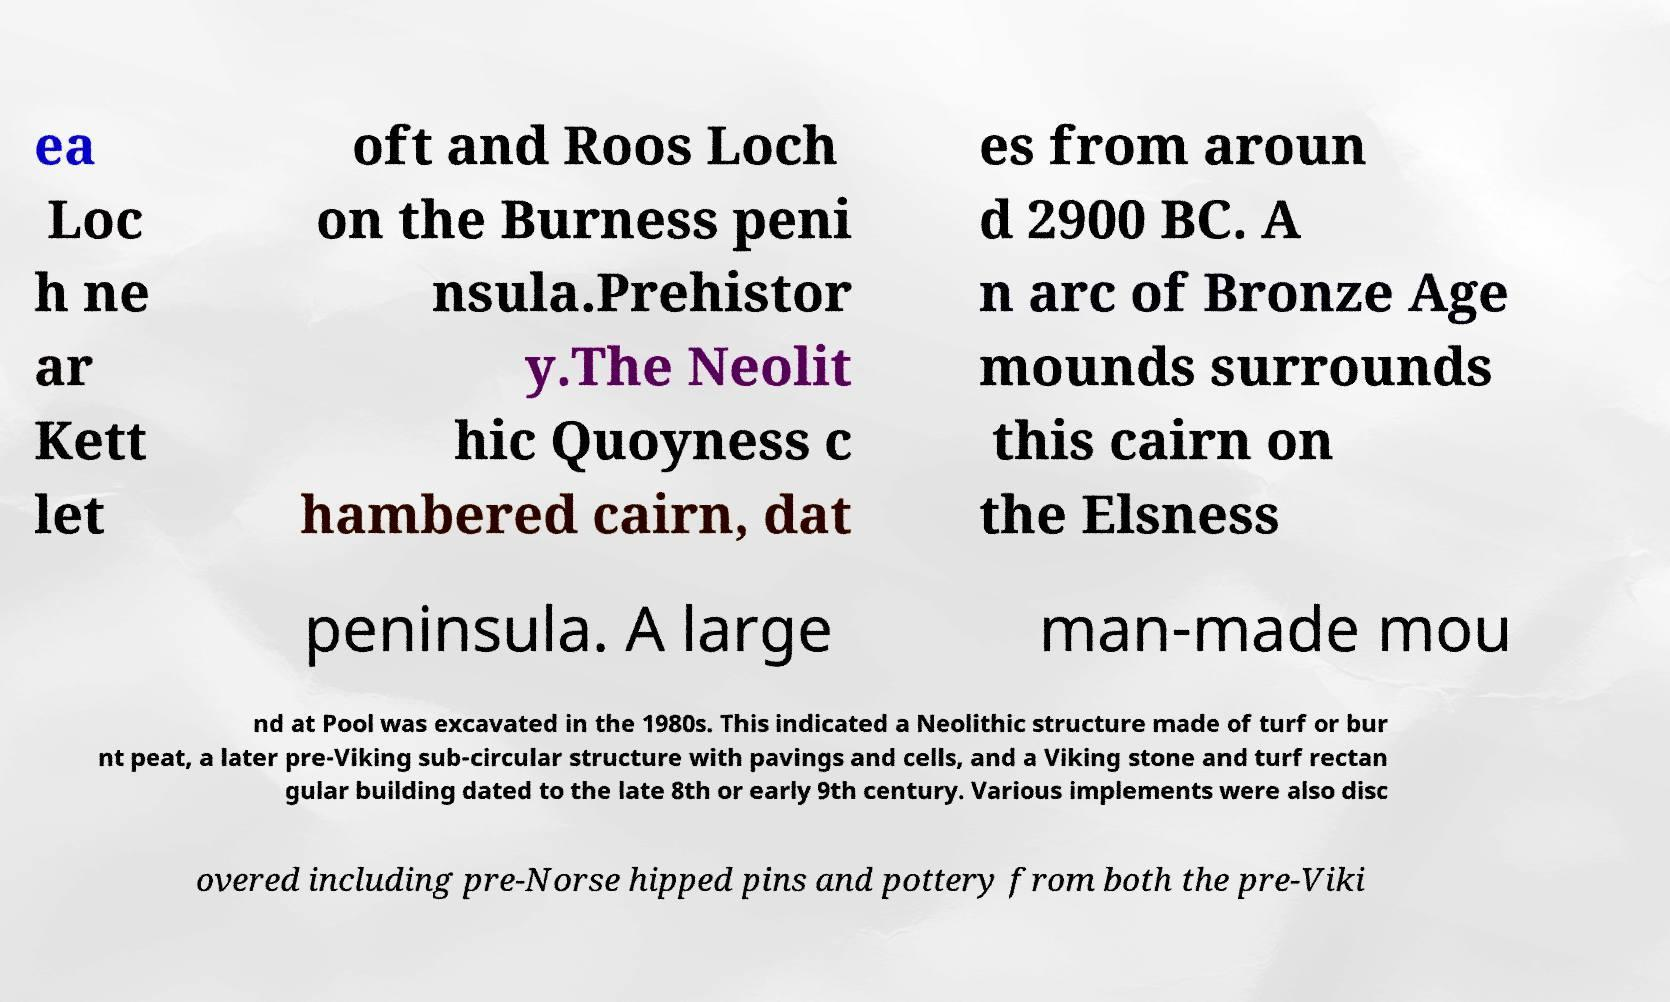Can you accurately transcribe the text from the provided image for me? ea Loc h ne ar Kett let oft and Roos Loch on the Burness peni nsula.Prehistor y.The Neolit hic Quoyness c hambered cairn, dat es from aroun d 2900 BC. A n arc of Bronze Age mounds surrounds this cairn on the Elsness peninsula. A large man-made mou nd at Pool was excavated in the 1980s. This indicated a Neolithic structure made of turf or bur nt peat, a later pre-Viking sub-circular structure with pavings and cells, and a Viking stone and turf rectan gular building dated to the late 8th or early 9th century. Various implements were also disc overed including pre-Norse hipped pins and pottery from both the pre-Viki 